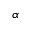Convert formula to latex. <formula><loc_0><loc_0><loc_500><loc_500>\alpha</formula> 